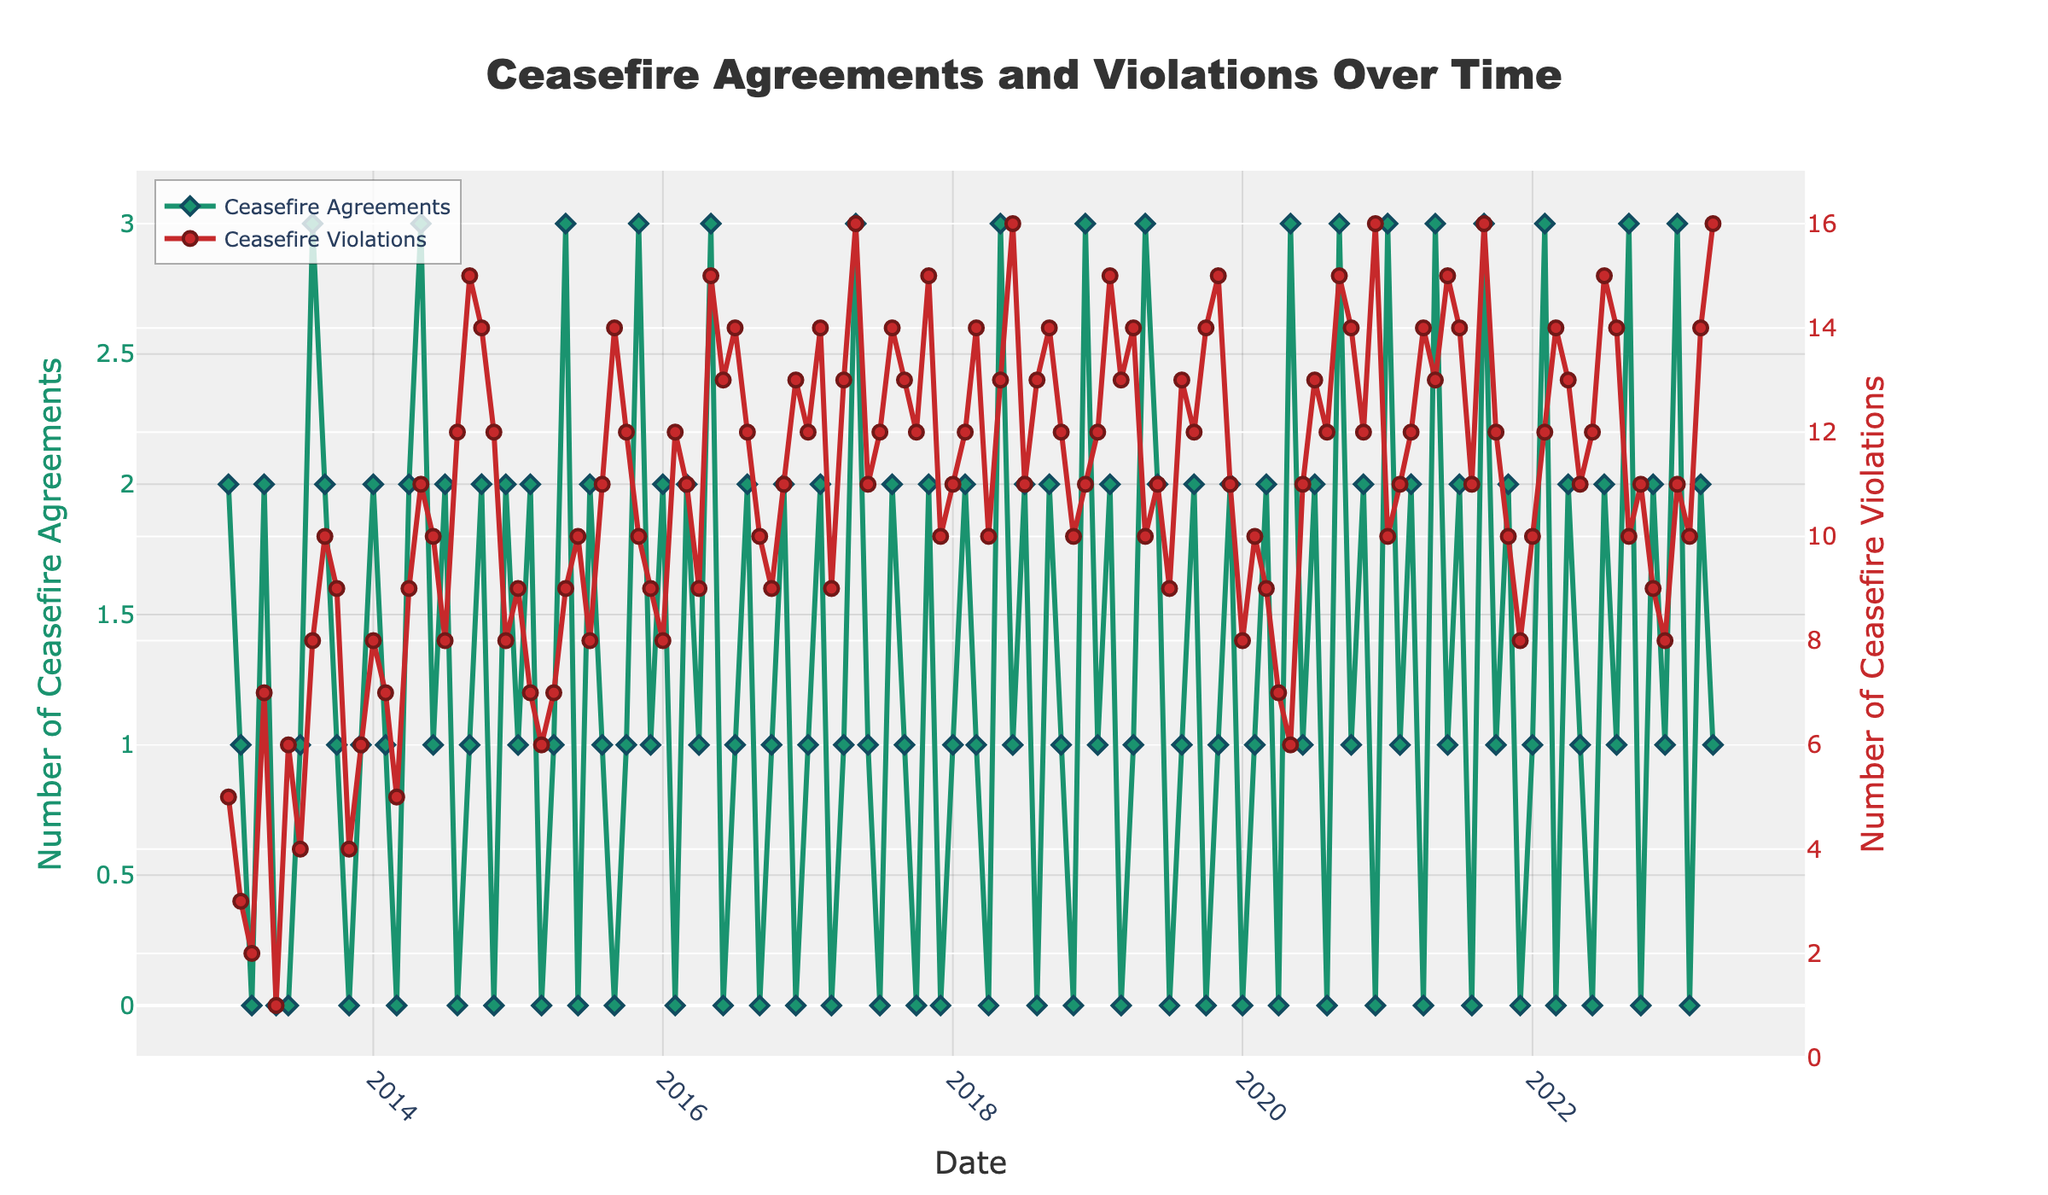What is the title of the plot? The title is located at the top of the figure in a large font. It reads: "Ceasefire Agreements and Violations Over Time."
Answer: Ceasefire Agreements and Violations Over Time How many data points are there for Ceasefire Violations? By counting each marker for Ceasefire Violations on the plot, we can see there are monthly data points from January 2013 to April 2023. This gives us a total of 124 points.
Answer: 124 Which year had the highest number of Ceasefire Violations in any single month, and what was that number? By reviewing the highest peaks on the Ceasefire Violations line, the highest peak corresponds to April 2023, which had 16 violations.
Answer: 2023, 16 Compare the values of Ceasefire Agreements and Violations for the month with the highest violations. By locating the point which represents the highest violations in April 2023 (16), we can see that the Ceasefire Agreements for the same month are 1.
Answer: Ceasefire Agreements: 1; Violations: 16 What is the general trend of Ceasefire Violations from 2013 to 2023? By observing the red line with circular markers, the trend shows a general increase in the number of Ceasefire Violations over the decade. There are fluctuations, but the overall direction is upwards.
Answer: Increasing In which months did Ceasefire Agreements equal Ceasefire Violations? By comparing the two lines directly, there are no months where the two lines intersect or share the same value.
Answer: None Are there any visible seasonal patterns in either Ceasefire Agreements or Violations? Looking at the dense clustering of data points for both lines throughout the years, there are no clear seasonal patterns for either metric.
Answer: No What's the difference between the maximum numbers of Ceasefire Agreements and Violations in 2015? The highest value for Ceasefire Agreements in 2015 is 3 (May, November), and the maximum for Violations is 14 (September). Therefore, the difference is 14 - 3 = 11.
Answer: 11 What is the most frequent number of Ceasefire Agreements per month? By observing the plot, the most frequent number for Ceasefire Agreements seems to be 1, as it appears recurrently throughout the timeline.
Answer: 1 How do the average numbers of Ceasefire Agreements and Violations compare for the entire decade? To calculate, we sum the values of Ceasefire Agreements and Violations across the entire decade and then divide by the number of months (124). For Ceasefire Agreements: (2 + 1 +...+1 + 2 + 1) / 124 ≈ (150/124) ≈ 1.21. For Violations: (5 + 3 + ... + 14 + 16) / 124 ≈ (1341/124) ≈ 10.82. The average number of Violations is significantly higher than the average number of Ceasefire Agreements.
Answer: Agreements: ~1.21, Violations: ~10.82 